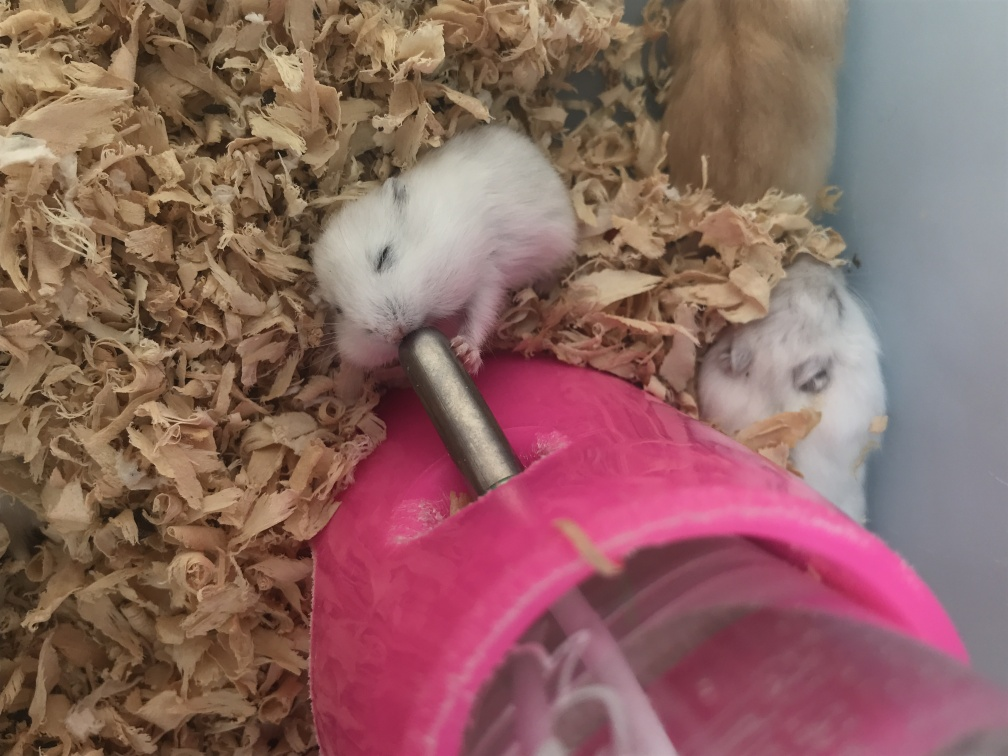Can you tell me more about what these animals are doing? These small rodents, likely hamsters, are gathered around a water bottle with a metal spout, which suggests they are drinking or about to drink. Their behavior indicates they are likely interacting with their environment, fulfilling basic needs such as hydration. 